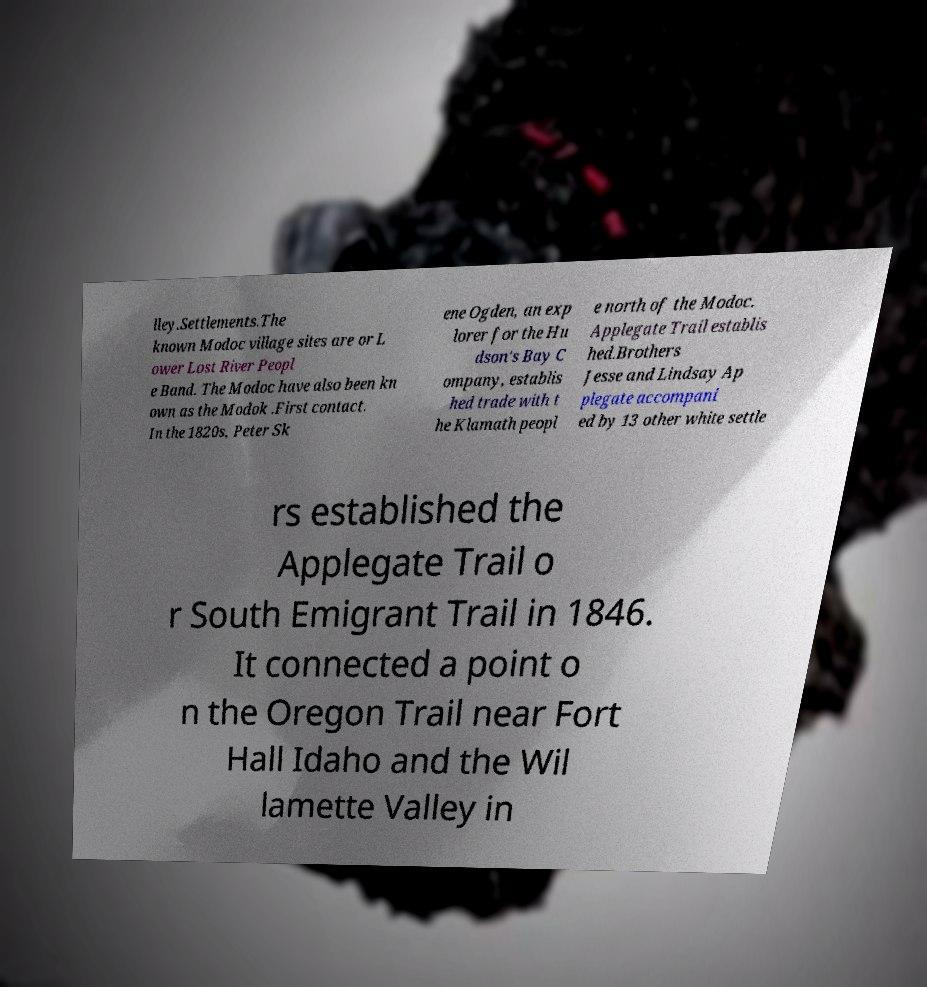Could you assist in decoding the text presented in this image and type it out clearly? lley.Settlements.The known Modoc village sites are or L ower Lost River Peopl e Band. The Modoc have also been kn own as the Modok .First contact. In the 1820s, Peter Sk ene Ogden, an exp lorer for the Hu dson's Bay C ompany, establis hed trade with t he Klamath peopl e north of the Modoc. Applegate Trail establis hed.Brothers Jesse and Lindsay Ap plegate accompani ed by 13 other white settle rs established the Applegate Trail o r South Emigrant Trail in 1846. It connected a point o n the Oregon Trail near Fort Hall Idaho and the Wil lamette Valley in 